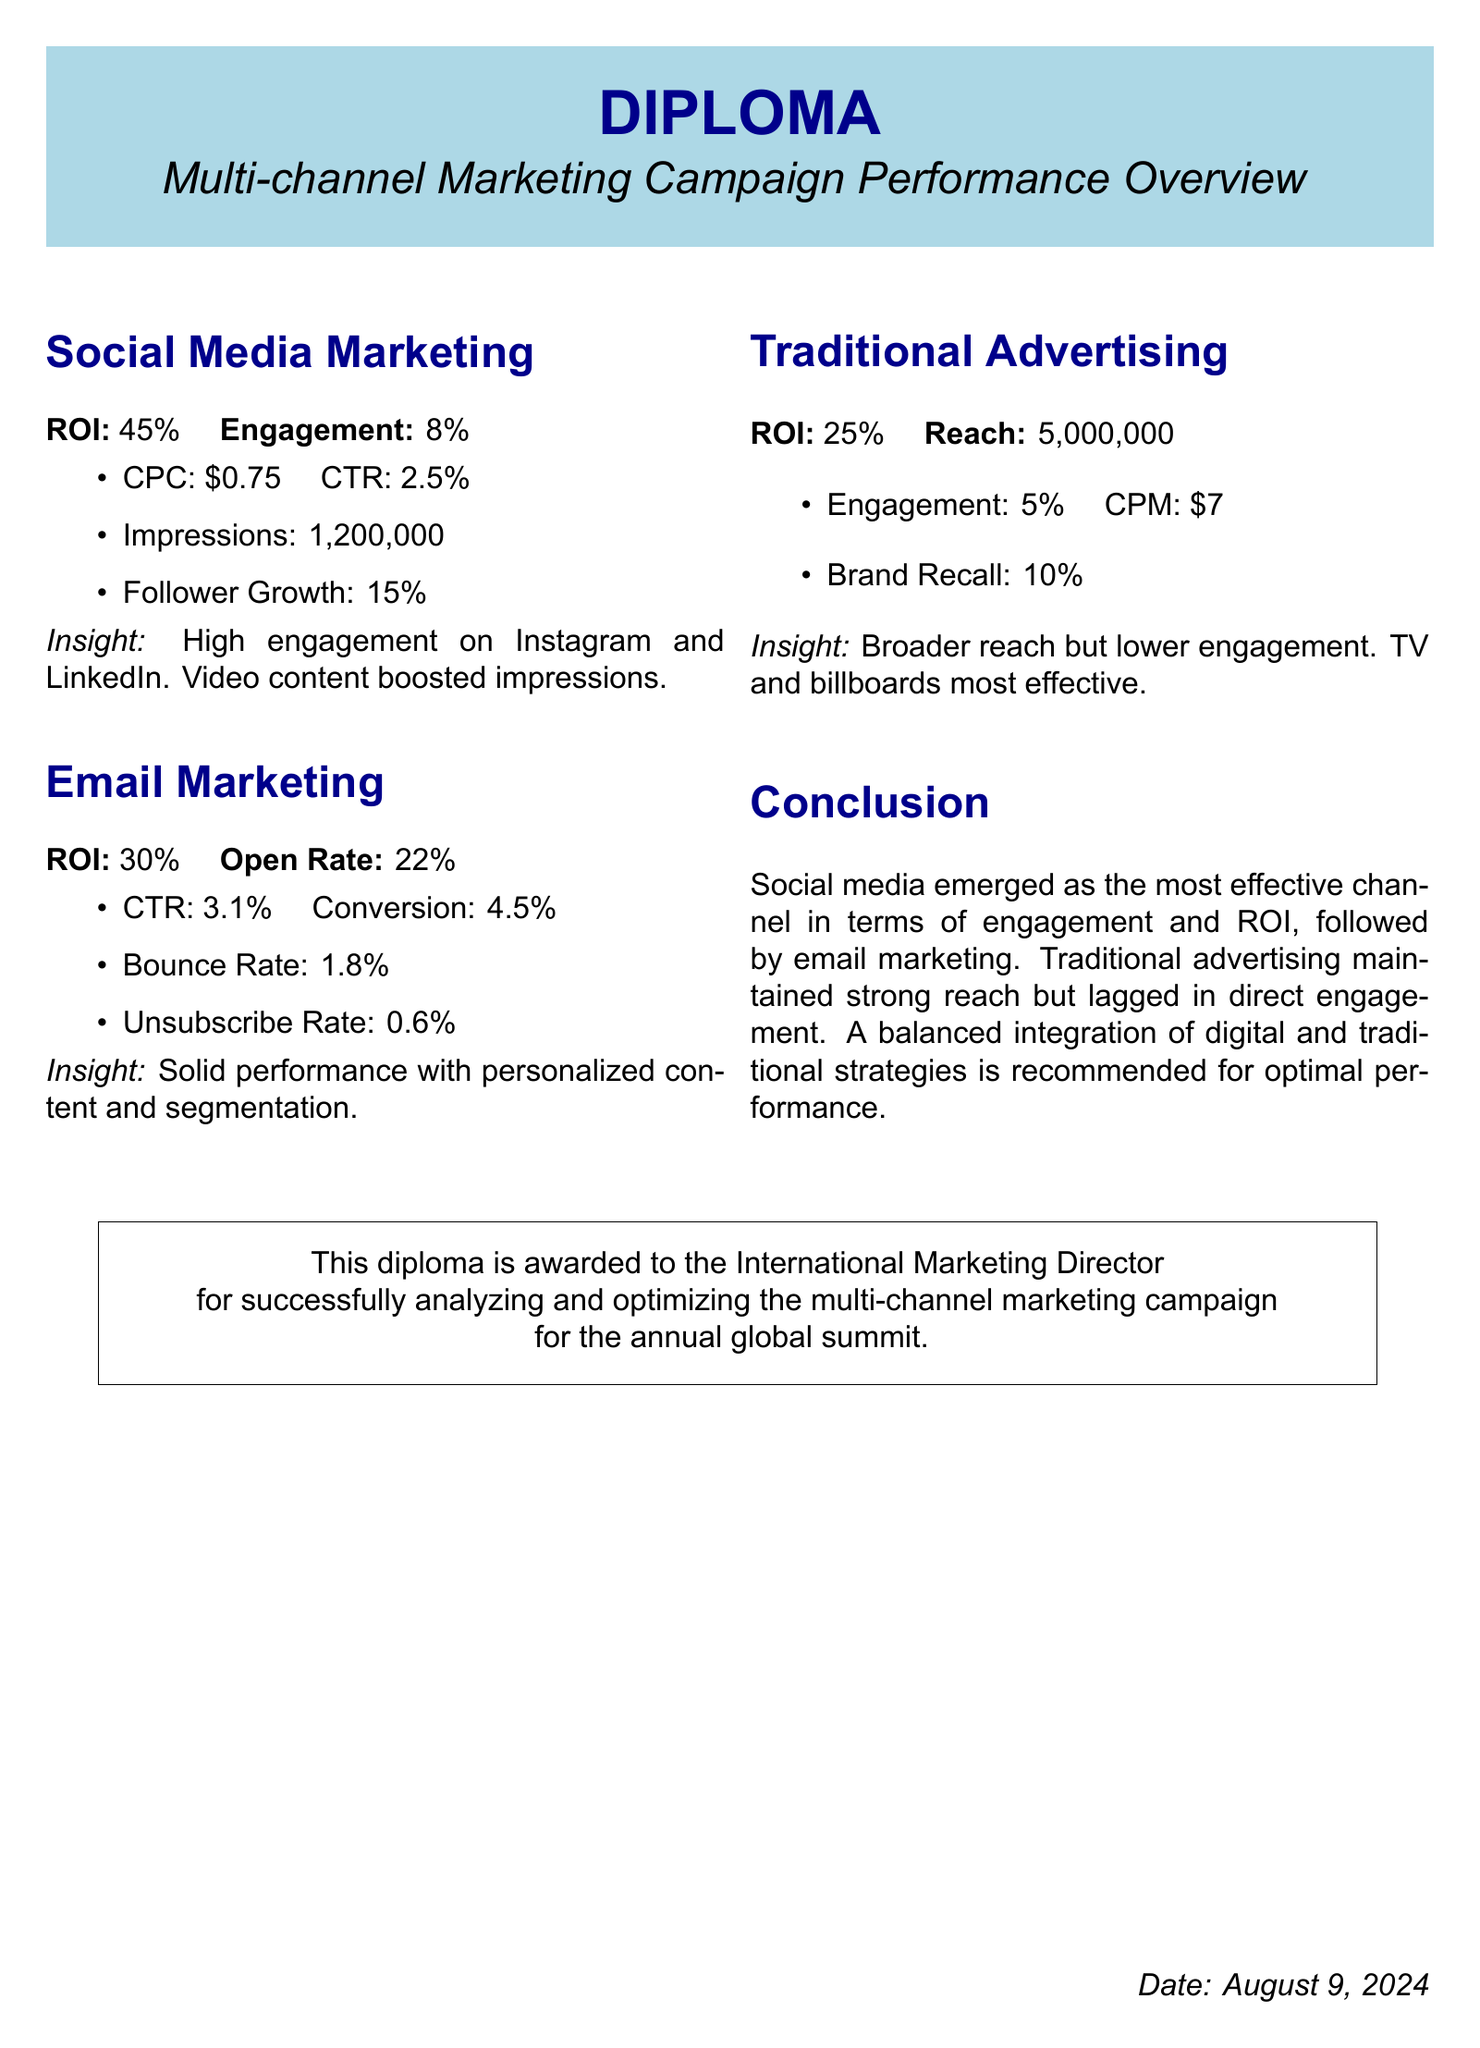What is the ROI for social media marketing? The ROI for social media marketing is specifically mentioned in the document.
Answer: 45% What engagement rate is reported for email marketing? The document provides an engagement rate for email marketing, which is key performance data.
Answer: 22% What was the reach of traditional advertising? The reach of traditional advertising is specifically stated in the document.
Answer: 5,000,000 Which channel showed the highest follower growth? The document notes the follower growth for social media marketing, highlighting its effectiveness.
Answer: 15% What is the CPM for traditional advertising? The document includes the CPM rate, which is a vital metric for analyzing advertising costs.
Answer: $7 Which marketing channel had the highest engagement? The document summarizes the engagement levels across channels, requiring reasoning over multiple pieces of information.
Answer: Social media What is the unsubscribe rate for email marketing? The document explicitly states the unsubscribe rate for email marketing.
Answer: 0.6% What insight is mentioned for social media marketing? The document provides insights drawn from the data, specifically for the social media channel.
Answer: High engagement on Instagram and LinkedIn Who is awarded this diploma? The diploma specifies the recipient, relevant to the document type and its purpose.
Answer: International Marketing Director 